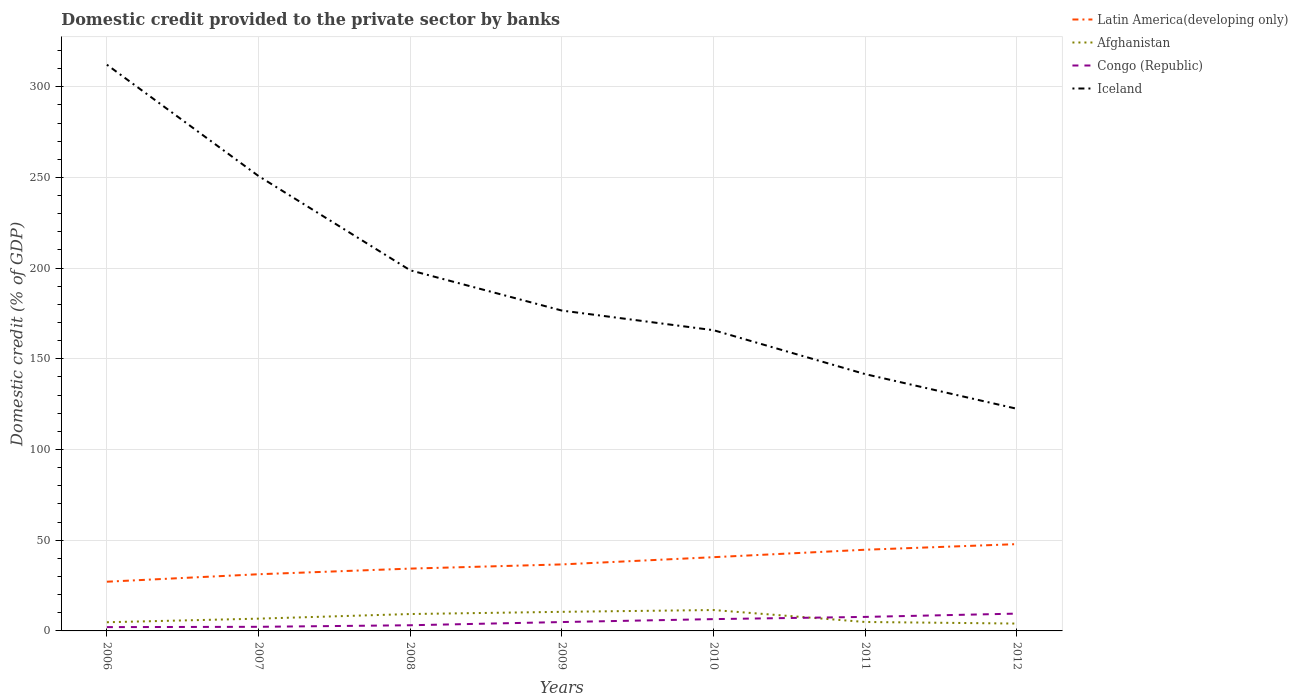How many different coloured lines are there?
Your response must be concise. 4. Is the number of lines equal to the number of legend labels?
Make the answer very short. Yes. Across all years, what is the maximum domestic credit provided to the private sector by banks in Iceland?
Ensure brevity in your answer.  122.46. In which year was the domestic credit provided to the private sector by banks in Afghanistan maximum?
Your answer should be very brief. 2012. What is the total domestic credit provided to the private sector by banks in Afghanistan in the graph?
Your response must be concise. 4.38. What is the difference between the highest and the second highest domestic credit provided to the private sector by banks in Afghanistan?
Give a very brief answer. 7.46. Is the domestic credit provided to the private sector by banks in Latin America(developing only) strictly greater than the domestic credit provided to the private sector by banks in Iceland over the years?
Provide a succinct answer. Yes. How many lines are there?
Your answer should be very brief. 4. How many years are there in the graph?
Offer a terse response. 7. What is the difference between two consecutive major ticks on the Y-axis?
Provide a short and direct response. 50. Are the values on the major ticks of Y-axis written in scientific E-notation?
Offer a terse response. No. How are the legend labels stacked?
Provide a short and direct response. Vertical. What is the title of the graph?
Keep it short and to the point. Domestic credit provided to the private sector by banks. Does "United States" appear as one of the legend labels in the graph?
Your answer should be compact. No. What is the label or title of the X-axis?
Your response must be concise. Years. What is the label or title of the Y-axis?
Offer a terse response. Domestic credit (% of GDP). What is the Domestic credit (% of GDP) of Latin America(developing only) in 2006?
Give a very brief answer. 27.13. What is the Domestic credit (% of GDP) in Afghanistan in 2006?
Your response must be concise. 4.78. What is the Domestic credit (% of GDP) in Congo (Republic) in 2006?
Offer a terse response. 2.1. What is the Domestic credit (% of GDP) of Iceland in 2006?
Your response must be concise. 312.15. What is the Domestic credit (% of GDP) in Latin America(developing only) in 2007?
Ensure brevity in your answer.  31.25. What is the Domestic credit (% of GDP) in Afghanistan in 2007?
Offer a very short reply. 6.77. What is the Domestic credit (% of GDP) of Congo (Republic) in 2007?
Your answer should be compact. 2.27. What is the Domestic credit (% of GDP) of Iceland in 2007?
Give a very brief answer. 250.76. What is the Domestic credit (% of GDP) of Latin America(developing only) in 2008?
Offer a very short reply. 34.35. What is the Domestic credit (% of GDP) in Afghanistan in 2008?
Give a very brief answer. 9.31. What is the Domestic credit (% of GDP) in Congo (Republic) in 2008?
Provide a short and direct response. 3.13. What is the Domestic credit (% of GDP) of Iceland in 2008?
Provide a succinct answer. 198.81. What is the Domestic credit (% of GDP) in Latin America(developing only) in 2009?
Make the answer very short. 36.67. What is the Domestic credit (% of GDP) in Afghanistan in 2009?
Your response must be concise. 10.53. What is the Domestic credit (% of GDP) in Congo (Republic) in 2009?
Give a very brief answer. 4.89. What is the Domestic credit (% of GDP) of Iceland in 2009?
Make the answer very short. 176.6. What is the Domestic credit (% of GDP) of Latin America(developing only) in 2010?
Keep it short and to the point. 40.65. What is the Domestic credit (% of GDP) in Afghanistan in 2010?
Your response must be concise. 11.52. What is the Domestic credit (% of GDP) in Congo (Republic) in 2010?
Give a very brief answer. 6.51. What is the Domestic credit (% of GDP) in Iceland in 2010?
Ensure brevity in your answer.  165.78. What is the Domestic credit (% of GDP) of Latin America(developing only) in 2011?
Keep it short and to the point. 44.76. What is the Domestic credit (% of GDP) of Afghanistan in 2011?
Ensure brevity in your answer.  4.93. What is the Domestic credit (% of GDP) of Congo (Republic) in 2011?
Make the answer very short. 7.73. What is the Domestic credit (% of GDP) of Iceland in 2011?
Your answer should be compact. 141.56. What is the Domestic credit (% of GDP) in Latin America(developing only) in 2012?
Give a very brief answer. 47.85. What is the Domestic credit (% of GDP) in Afghanistan in 2012?
Provide a succinct answer. 4.05. What is the Domestic credit (% of GDP) in Congo (Republic) in 2012?
Your answer should be compact. 9.54. What is the Domestic credit (% of GDP) of Iceland in 2012?
Give a very brief answer. 122.46. Across all years, what is the maximum Domestic credit (% of GDP) in Latin America(developing only)?
Offer a terse response. 47.85. Across all years, what is the maximum Domestic credit (% of GDP) in Afghanistan?
Your response must be concise. 11.52. Across all years, what is the maximum Domestic credit (% of GDP) of Congo (Republic)?
Provide a short and direct response. 9.54. Across all years, what is the maximum Domestic credit (% of GDP) of Iceland?
Make the answer very short. 312.15. Across all years, what is the minimum Domestic credit (% of GDP) of Latin America(developing only)?
Your response must be concise. 27.13. Across all years, what is the minimum Domestic credit (% of GDP) of Afghanistan?
Give a very brief answer. 4.05. Across all years, what is the minimum Domestic credit (% of GDP) in Congo (Republic)?
Ensure brevity in your answer.  2.1. Across all years, what is the minimum Domestic credit (% of GDP) in Iceland?
Your response must be concise. 122.46. What is the total Domestic credit (% of GDP) in Latin America(developing only) in the graph?
Provide a short and direct response. 262.65. What is the total Domestic credit (% of GDP) in Afghanistan in the graph?
Your answer should be compact. 51.89. What is the total Domestic credit (% of GDP) of Congo (Republic) in the graph?
Your answer should be very brief. 36.17. What is the total Domestic credit (% of GDP) of Iceland in the graph?
Your answer should be compact. 1368.13. What is the difference between the Domestic credit (% of GDP) in Latin America(developing only) in 2006 and that in 2007?
Your response must be concise. -4.12. What is the difference between the Domestic credit (% of GDP) of Afghanistan in 2006 and that in 2007?
Ensure brevity in your answer.  -1.99. What is the difference between the Domestic credit (% of GDP) in Congo (Republic) in 2006 and that in 2007?
Keep it short and to the point. -0.17. What is the difference between the Domestic credit (% of GDP) of Iceland in 2006 and that in 2007?
Offer a very short reply. 61.39. What is the difference between the Domestic credit (% of GDP) in Latin America(developing only) in 2006 and that in 2008?
Provide a short and direct response. -7.22. What is the difference between the Domestic credit (% of GDP) in Afghanistan in 2006 and that in 2008?
Your answer should be very brief. -4.53. What is the difference between the Domestic credit (% of GDP) in Congo (Republic) in 2006 and that in 2008?
Give a very brief answer. -1.03. What is the difference between the Domestic credit (% of GDP) in Iceland in 2006 and that in 2008?
Make the answer very short. 113.35. What is the difference between the Domestic credit (% of GDP) of Latin America(developing only) in 2006 and that in 2009?
Provide a short and direct response. -9.54. What is the difference between the Domestic credit (% of GDP) of Afghanistan in 2006 and that in 2009?
Offer a terse response. -5.74. What is the difference between the Domestic credit (% of GDP) of Congo (Republic) in 2006 and that in 2009?
Your response must be concise. -2.79. What is the difference between the Domestic credit (% of GDP) in Iceland in 2006 and that in 2009?
Your answer should be very brief. 135.55. What is the difference between the Domestic credit (% of GDP) of Latin America(developing only) in 2006 and that in 2010?
Your response must be concise. -13.52. What is the difference between the Domestic credit (% of GDP) in Afghanistan in 2006 and that in 2010?
Make the answer very short. -6.73. What is the difference between the Domestic credit (% of GDP) of Congo (Republic) in 2006 and that in 2010?
Provide a succinct answer. -4.41. What is the difference between the Domestic credit (% of GDP) of Iceland in 2006 and that in 2010?
Offer a very short reply. 146.37. What is the difference between the Domestic credit (% of GDP) in Latin America(developing only) in 2006 and that in 2011?
Your answer should be compact. -17.63. What is the difference between the Domestic credit (% of GDP) in Afghanistan in 2006 and that in 2011?
Your answer should be very brief. -0.14. What is the difference between the Domestic credit (% of GDP) in Congo (Republic) in 2006 and that in 2011?
Provide a succinct answer. -5.63. What is the difference between the Domestic credit (% of GDP) of Iceland in 2006 and that in 2011?
Offer a terse response. 170.59. What is the difference between the Domestic credit (% of GDP) in Latin America(developing only) in 2006 and that in 2012?
Keep it short and to the point. -20.72. What is the difference between the Domestic credit (% of GDP) of Afghanistan in 2006 and that in 2012?
Your response must be concise. 0.73. What is the difference between the Domestic credit (% of GDP) of Congo (Republic) in 2006 and that in 2012?
Ensure brevity in your answer.  -7.45. What is the difference between the Domestic credit (% of GDP) of Iceland in 2006 and that in 2012?
Ensure brevity in your answer.  189.69. What is the difference between the Domestic credit (% of GDP) in Latin America(developing only) in 2007 and that in 2008?
Keep it short and to the point. -3.11. What is the difference between the Domestic credit (% of GDP) in Afghanistan in 2007 and that in 2008?
Keep it short and to the point. -2.54. What is the difference between the Domestic credit (% of GDP) of Congo (Republic) in 2007 and that in 2008?
Your answer should be very brief. -0.86. What is the difference between the Domestic credit (% of GDP) in Iceland in 2007 and that in 2008?
Offer a terse response. 51.96. What is the difference between the Domestic credit (% of GDP) in Latin America(developing only) in 2007 and that in 2009?
Offer a terse response. -5.42. What is the difference between the Domestic credit (% of GDP) of Afghanistan in 2007 and that in 2009?
Your answer should be compact. -3.76. What is the difference between the Domestic credit (% of GDP) in Congo (Republic) in 2007 and that in 2009?
Your response must be concise. -2.62. What is the difference between the Domestic credit (% of GDP) of Iceland in 2007 and that in 2009?
Provide a short and direct response. 74.16. What is the difference between the Domestic credit (% of GDP) in Latin America(developing only) in 2007 and that in 2010?
Your response must be concise. -9.4. What is the difference between the Domestic credit (% of GDP) in Afghanistan in 2007 and that in 2010?
Provide a short and direct response. -4.75. What is the difference between the Domestic credit (% of GDP) of Congo (Republic) in 2007 and that in 2010?
Your answer should be very brief. -4.24. What is the difference between the Domestic credit (% of GDP) of Iceland in 2007 and that in 2010?
Keep it short and to the point. 84.98. What is the difference between the Domestic credit (% of GDP) of Latin America(developing only) in 2007 and that in 2011?
Ensure brevity in your answer.  -13.51. What is the difference between the Domestic credit (% of GDP) of Afghanistan in 2007 and that in 2011?
Give a very brief answer. 1.84. What is the difference between the Domestic credit (% of GDP) in Congo (Republic) in 2007 and that in 2011?
Offer a terse response. -5.46. What is the difference between the Domestic credit (% of GDP) in Iceland in 2007 and that in 2011?
Keep it short and to the point. 109.2. What is the difference between the Domestic credit (% of GDP) of Latin America(developing only) in 2007 and that in 2012?
Your response must be concise. -16.6. What is the difference between the Domestic credit (% of GDP) in Afghanistan in 2007 and that in 2012?
Offer a terse response. 2.72. What is the difference between the Domestic credit (% of GDP) in Congo (Republic) in 2007 and that in 2012?
Your answer should be compact. -7.28. What is the difference between the Domestic credit (% of GDP) of Iceland in 2007 and that in 2012?
Your answer should be very brief. 128.3. What is the difference between the Domestic credit (% of GDP) in Latin America(developing only) in 2008 and that in 2009?
Give a very brief answer. -2.31. What is the difference between the Domestic credit (% of GDP) of Afghanistan in 2008 and that in 2009?
Offer a very short reply. -1.21. What is the difference between the Domestic credit (% of GDP) of Congo (Republic) in 2008 and that in 2009?
Make the answer very short. -1.77. What is the difference between the Domestic credit (% of GDP) of Iceland in 2008 and that in 2009?
Your response must be concise. 22.2. What is the difference between the Domestic credit (% of GDP) in Latin America(developing only) in 2008 and that in 2010?
Provide a short and direct response. -6.3. What is the difference between the Domestic credit (% of GDP) of Afghanistan in 2008 and that in 2010?
Provide a succinct answer. -2.2. What is the difference between the Domestic credit (% of GDP) of Congo (Republic) in 2008 and that in 2010?
Make the answer very short. -3.38. What is the difference between the Domestic credit (% of GDP) in Iceland in 2008 and that in 2010?
Give a very brief answer. 33.02. What is the difference between the Domestic credit (% of GDP) in Latin America(developing only) in 2008 and that in 2011?
Offer a terse response. -10.41. What is the difference between the Domestic credit (% of GDP) in Afghanistan in 2008 and that in 2011?
Offer a terse response. 4.38. What is the difference between the Domestic credit (% of GDP) in Congo (Republic) in 2008 and that in 2011?
Offer a very short reply. -4.61. What is the difference between the Domestic credit (% of GDP) of Iceland in 2008 and that in 2011?
Your response must be concise. 57.25. What is the difference between the Domestic credit (% of GDP) of Latin America(developing only) in 2008 and that in 2012?
Provide a short and direct response. -13.49. What is the difference between the Domestic credit (% of GDP) of Afghanistan in 2008 and that in 2012?
Provide a short and direct response. 5.26. What is the difference between the Domestic credit (% of GDP) of Congo (Republic) in 2008 and that in 2012?
Your answer should be compact. -6.42. What is the difference between the Domestic credit (% of GDP) in Iceland in 2008 and that in 2012?
Make the answer very short. 76.35. What is the difference between the Domestic credit (% of GDP) in Latin America(developing only) in 2009 and that in 2010?
Keep it short and to the point. -3.98. What is the difference between the Domestic credit (% of GDP) in Afghanistan in 2009 and that in 2010?
Your response must be concise. -0.99. What is the difference between the Domestic credit (% of GDP) of Congo (Republic) in 2009 and that in 2010?
Make the answer very short. -1.62. What is the difference between the Domestic credit (% of GDP) of Iceland in 2009 and that in 2010?
Offer a terse response. 10.82. What is the difference between the Domestic credit (% of GDP) of Latin America(developing only) in 2009 and that in 2011?
Provide a short and direct response. -8.09. What is the difference between the Domestic credit (% of GDP) in Afghanistan in 2009 and that in 2011?
Keep it short and to the point. 5.6. What is the difference between the Domestic credit (% of GDP) of Congo (Republic) in 2009 and that in 2011?
Give a very brief answer. -2.84. What is the difference between the Domestic credit (% of GDP) of Iceland in 2009 and that in 2011?
Keep it short and to the point. 35.04. What is the difference between the Domestic credit (% of GDP) of Latin America(developing only) in 2009 and that in 2012?
Give a very brief answer. -11.18. What is the difference between the Domestic credit (% of GDP) in Afghanistan in 2009 and that in 2012?
Your answer should be compact. 6.47. What is the difference between the Domestic credit (% of GDP) in Congo (Republic) in 2009 and that in 2012?
Offer a terse response. -4.65. What is the difference between the Domestic credit (% of GDP) of Iceland in 2009 and that in 2012?
Make the answer very short. 54.14. What is the difference between the Domestic credit (% of GDP) in Latin America(developing only) in 2010 and that in 2011?
Provide a short and direct response. -4.11. What is the difference between the Domestic credit (% of GDP) in Afghanistan in 2010 and that in 2011?
Your answer should be compact. 6.59. What is the difference between the Domestic credit (% of GDP) of Congo (Republic) in 2010 and that in 2011?
Ensure brevity in your answer.  -1.22. What is the difference between the Domestic credit (% of GDP) in Iceland in 2010 and that in 2011?
Ensure brevity in your answer.  24.22. What is the difference between the Domestic credit (% of GDP) of Latin America(developing only) in 2010 and that in 2012?
Give a very brief answer. -7.19. What is the difference between the Domestic credit (% of GDP) in Afghanistan in 2010 and that in 2012?
Keep it short and to the point. 7.46. What is the difference between the Domestic credit (% of GDP) in Congo (Republic) in 2010 and that in 2012?
Make the answer very short. -3.04. What is the difference between the Domestic credit (% of GDP) in Iceland in 2010 and that in 2012?
Ensure brevity in your answer.  43.32. What is the difference between the Domestic credit (% of GDP) in Latin America(developing only) in 2011 and that in 2012?
Make the answer very short. -3.09. What is the difference between the Domestic credit (% of GDP) in Congo (Republic) in 2011 and that in 2012?
Your answer should be compact. -1.81. What is the difference between the Domestic credit (% of GDP) in Iceland in 2011 and that in 2012?
Your answer should be very brief. 19.1. What is the difference between the Domestic credit (% of GDP) in Latin America(developing only) in 2006 and the Domestic credit (% of GDP) in Afghanistan in 2007?
Your response must be concise. 20.36. What is the difference between the Domestic credit (% of GDP) in Latin America(developing only) in 2006 and the Domestic credit (% of GDP) in Congo (Republic) in 2007?
Offer a terse response. 24.86. What is the difference between the Domestic credit (% of GDP) in Latin America(developing only) in 2006 and the Domestic credit (% of GDP) in Iceland in 2007?
Give a very brief answer. -223.63. What is the difference between the Domestic credit (% of GDP) of Afghanistan in 2006 and the Domestic credit (% of GDP) of Congo (Republic) in 2007?
Provide a succinct answer. 2.52. What is the difference between the Domestic credit (% of GDP) in Afghanistan in 2006 and the Domestic credit (% of GDP) in Iceland in 2007?
Your answer should be compact. -245.98. What is the difference between the Domestic credit (% of GDP) in Congo (Republic) in 2006 and the Domestic credit (% of GDP) in Iceland in 2007?
Your answer should be very brief. -248.67. What is the difference between the Domestic credit (% of GDP) of Latin America(developing only) in 2006 and the Domestic credit (% of GDP) of Afghanistan in 2008?
Keep it short and to the point. 17.82. What is the difference between the Domestic credit (% of GDP) of Latin America(developing only) in 2006 and the Domestic credit (% of GDP) of Congo (Republic) in 2008?
Your answer should be very brief. 24. What is the difference between the Domestic credit (% of GDP) of Latin America(developing only) in 2006 and the Domestic credit (% of GDP) of Iceland in 2008?
Provide a succinct answer. -171.68. What is the difference between the Domestic credit (% of GDP) in Afghanistan in 2006 and the Domestic credit (% of GDP) in Congo (Republic) in 2008?
Provide a succinct answer. 1.66. What is the difference between the Domestic credit (% of GDP) of Afghanistan in 2006 and the Domestic credit (% of GDP) of Iceland in 2008?
Your answer should be compact. -194.02. What is the difference between the Domestic credit (% of GDP) in Congo (Republic) in 2006 and the Domestic credit (% of GDP) in Iceland in 2008?
Provide a short and direct response. -196.71. What is the difference between the Domestic credit (% of GDP) in Latin America(developing only) in 2006 and the Domestic credit (% of GDP) in Afghanistan in 2009?
Keep it short and to the point. 16.6. What is the difference between the Domestic credit (% of GDP) of Latin America(developing only) in 2006 and the Domestic credit (% of GDP) of Congo (Republic) in 2009?
Provide a short and direct response. 22.24. What is the difference between the Domestic credit (% of GDP) of Latin America(developing only) in 2006 and the Domestic credit (% of GDP) of Iceland in 2009?
Offer a very short reply. -149.47. What is the difference between the Domestic credit (% of GDP) in Afghanistan in 2006 and the Domestic credit (% of GDP) in Congo (Republic) in 2009?
Your response must be concise. -0.11. What is the difference between the Domestic credit (% of GDP) in Afghanistan in 2006 and the Domestic credit (% of GDP) in Iceland in 2009?
Provide a succinct answer. -171.82. What is the difference between the Domestic credit (% of GDP) in Congo (Republic) in 2006 and the Domestic credit (% of GDP) in Iceland in 2009?
Offer a terse response. -174.5. What is the difference between the Domestic credit (% of GDP) in Latin America(developing only) in 2006 and the Domestic credit (% of GDP) in Afghanistan in 2010?
Your answer should be compact. 15.61. What is the difference between the Domestic credit (% of GDP) of Latin America(developing only) in 2006 and the Domestic credit (% of GDP) of Congo (Republic) in 2010?
Keep it short and to the point. 20.62. What is the difference between the Domestic credit (% of GDP) of Latin America(developing only) in 2006 and the Domestic credit (% of GDP) of Iceland in 2010?
Keep it short and to the point. -138.66. What is the difference between the Domestic credit (% of GDP) in Afghanistan in 2006 and the Domestic credit (% of GDP) in Congo (Republic) in 2010?
Offer a terse response. -1.73. What is the difference between the Domestic credit (% of GDP) in Afghanistan in 2006 and the Domestic credit (% of GDP) in Iceland in 2010?
Keep it short and to the point. -161. What is the difference between the Domestic credit (% of GDP) in Congo (Republic) in 2006 and the Domestic credit (% of GDP) in Iceland in 2010?
Offer a very short reply. -163.69. What is the difference between the Domestic credit (% of GDP) of Latin America(developing only) in 2006 and the Domestic credit (% of GDP) of Afghanistan in 2011?
Keep it short and to the point. 22.2. What is the difference between the Domestic credit (% of GDP) in Latin America(developing only) in 2006 and the Domestic credit (% of GDP) in Congo (Republic) in 2011?
Provide a short and direct response. 19.4. What is the difference between the Domestic credit (% of GDP) in Latin America(developing only) in 2006 and the Domestic credit (% of GDP) in Iceland in 2011?
Offer a very short reply. -114.43. What is the difference between the Domestic credit (% of GDP) of Afghanistan in 2006 and the Domestic credit (% of GDP) of Congo (Republic) in 2011?
Offer a terse response. -2.95. What is the difference between the Domestic credit (% of GDP) in Afghanistan in 2006 and the Domestic credit (% of GDP) in Iceland in 2011?
Your answer should be very brief. -136.78. What is the difference between the Domestic credit (% of GDP) in Congo (Republic) in 2006 and the Domestic credit (% of GDP) in Iceland in 2011?
Provide a succinct answer. -139.46. What is the difference between the Domestic credit (% of GDP) of Latin America(developing only) in 2006 and the Domestic credit (% of GDP) of Afghanistan in 2012?
Make the answer very short. 23.08. What is the difference between the Domestic credit (% of GDP) in Latin America(developing only) in 2006 and the Domestic credit (% of GDP) in Congo (Republic) in 2012?
Your answer should be compact. 17.58. What is the difference between the Domestic credit (% of GDP) in Latin America(developing only) in 2006 and the Domestic credit (% of GDP) in Iceland in 2012?
Provide a succinct answer. -95.33. What is the difference between the Domestic credit (% of GDP) in Afghanistan in 2006 and the Domestic credit (% of GDP) in Congo (Republic) in 2012?
Keep it short and to the point. -4.76. What is the difference between the Domestic credit (% of GDP) of Afghanistan in 2006 and the Domestic credit (% of GDP) of Iceland in 2012?
Make the answer very short. -117.68. What is the difference between the Domestic credit (% of GDP) in Congo (Republic) in 2006 and the Domestic credit (% of GDP) in Iceland in 2012?
Your answer should be very brief. -120.36. What is the difference between the Domestic credit (% of GDP) in Latin America(developing only) in 2007 and the Domestic credit (% of GDP) in Afghanistan in 2008?
Give a very brief answer. 21.93. What is the difference between the Domestic credit (% of GDP) of Latin America(developing only) in 2007 and the Domestic credit (% of GDP) of Congo (Republic) in 2008?
Ensure brevity in your answer.  28.12. What is the difference between the Domestic credit (% of GDP) of Latin America(developing only) in 2007 and the Domestic credit (% of GDP) of Iceland in 2008?
Your answer should be very brief. -167.56. What is the difference between the Domestic credit (% of GDP) in Afghanistan in 2007 and the Domestic credit (% of GDP) in Congo (Republic) in 2008?
Provide a short and direct response. 3.65. What is the difference between the Domestic credit (% of GDP) of Afghanistan in 2007 and the Domestic credit (% of GDP) of Iceland in 2008?
Give a very brief answer. -192.04. What is the difference between the Domestic credit (% of GDP) in Congo (Republic) in 2007 and the Domestic credit (% of GDP) in Iceland in 2008?
Ensure brevity in your answer.  -196.54. What is the difference between the Domestic credit (% of GDP) in Latin America(developing only) in 2007 and the Domestic credit (% of GDP) in Afghanistan in 2009?
Give a very brief answer. 20.72. What is the difference between the Domestic credit (% of GDP) in Latin America(developing only) in 2007 and the Domestic credit (% of GDP) in Congo (Republic) in 2009?
Provide a short and direct response. 26.36. What is the difference between the Domestic credit (% of GDP) in Latin America(developing only) in 2007 and the Domestic credit (% of GDP) in Iceland in 2009?
Provide a succinct answer. -145.35. What is the difference between the Domestic credit (% of GDP) in Afghanistan in 2007 and the Domestic credit (% of GDP) in Congo (Republic) in 2009?
Ensure brevity in your answer.  1.88. What is the difference between the Domestic credit (% of GDP) in Afghanistan in 2007 and the Domestic credit (% of GDP) in Iceland in 2009?
Offer a very short reply. -169.83. What is the difference between the Domestic credit (% of GDP) in Congo (Republic) in 2007 and the Domestic credit (% of GDP) in Iceland in 2009?
Ensure brevity in your answer.  -174.33. What is the difference between the Domestic credit (% of GDP) in Latin America(developing only) in 2007 and the Domestic credit (% of GDP) in Afghanistan in 2010?
Provide a short and direct response. 19.73. What is the difference between the Domestic credit (% of GDP) of Latin America(developing only) in 2007 and the Domestic credit (% of GDP) of Congo (Republic) in 2010?
Offer a terse response. 24.74. What is the difference between the Domestic credit (% of GDP) in Latin America(developing only) in 2007 and the Domestic credit (% of GDP) in Iceland in 2010?
Ensure brevity in your answer.  -134.54. What is the difference between the Domestic credit (% of GDP) of Afghanistan in 2007 and the Domestic credit (% of GDP) of Congo (Republic) in 2010?
Give a very brief answer. 0.26. What is the difference between the Domestic credit (% of GDP) in Afghanistan in 2007 and the Domestic credit (% of GDP) in Iceland in 2010?
Provide a succinct answer. -159.01. What is the difference between the Domestic credit (% of GDP) of Congo (Republic) in 2007 and the Domestic credit (% of GDP) of Iceland in 2010?
Keep it short and to the point. -163.52. What is the difference between the Domestic credit (% of GDP) of Latin America(developing only) in 2007 and the Domestic credit (% of GDP) of Afghanistan in 2011?
Offer a very short reply. 26.32. What is the difference between the Domestic credit (% of GDP) of Latin America(developing only) in 2007 and the Domestic credit (% of GDP) of Congo (Republic) in 2011?
Your answer should be very brief. 23.52. What is the difference between the Domestic credit (% of GDP) of Latin America(developing only) in 2007 and the Domestic credit (% of GDP) of Iceland in 2011?
Provide a succinct answer. -110.31. What is the difference between the Domestic credit (% of GDP) of Afghanistan in 2007 and the Domestic credit (% of GDP) of Congo (Republic) in 2011?
Offer a terse response. -0.96. What is the difference between the Domestic credit (% of GDP) in Afghanistan in 2007 and the Domestic credit (% of GDP) in Iceland in 2011?
Your answer should be very brief. -134.79. What is the difference between the Domestic credit (% of GDP) of Congo (Republic) in 2007 and the Domestic credit (% of GDP) of Iceland in 2011?
Keep it short and to the point. -139.29. What is the difference between the Domestic credit (% of GDP) in Latin America(developing only) in 2007 and the Domestic credit (% of GDP) in Afghanistan in 2012?
Keep it short and to the point. 27.19. What is the difference between the Domestic credit (% of GDP) in Latin America(developing only) in 2007 and the Domestic credit (% of GDP) in Congo (Republic) in 2012?
Give a very brief answer. 21.7. What is the difference between the Domestic credit (% of GDP) in Latin America(developing only) in 2007 and the Domestic credit (% of GDP) in Iceland in 2012?
Your answer should be compact. -91.21. What is the difference between the Domestic credit (% of GDP) in Afghanistan in 2007 and the Domestic credit (% of GDP) in Congo (Republic) in 2012?
Your answer should be compact. -2.77. What is the difference between the Domestic credit (% of GDP) in Afghanistan in 2007 and the Domestic credit (% of GDP) in Iceland in 2012?
Keep it short and to the point. -115.69. What is the difference between the Domestic credit (% of GDP) in Congo (Republic) in 2007 and the Domestic credit (% of GDP) in Iceland in 2012?
Keep it short and to the point. -120.19. What is the difference between the Domestic credit (% of GDP) of Latin America(developing only) in 2008 and the Domestic credit (% of GDP) of Afghanistan in 2009?
Make the answer very short. 23.83. What is the difference between the Domestic credit (% of GDP) of Latin America(developing only) in 2008 and the Domestic credit (% of GDP) of Congo (Republic) in 2009?
Provide a succinct answer. 29.46. What is the difference between the Domestic credit (% of GDP) of Latin America(developing only) in 2008 and the Domestic credit (% of GDP) of Iceland in 2009?
Give a very brief answer. -142.25. What is the difference between the Domestic credit (% of GDP) in Afghanistan in 2008 and the Domestic credit (% of GDP) in Congo (Republic) in 2009?
Make the answer very short. 4.42. What is the difference between the Domestic credit (% of GDP) in Afghanistan in 2008 and the Domestic credit (% of GDP) in Iceland in 2009?
Your response must be concise. -167.29. What is the difference between the Domestic credit (% of GDP) in Congo (Republic) in 2008 and the Domestic credit (% of GDP) in Iceland in 2009?
Make the answer very short. -173.48. What is the difference between the Domestic credit (% of GDP) in Latin America(developing only) in 2008 and the Domestic credit (% of GDP) in Afghanistan in 2010?
Give a very brief answer. 22.84. What is the difference between the Domestic credit (% of GDP) in Latin America(developing only) in 2008 and the Domestic credit (% of GDP) in Congo (Republic) in 2010?
Give a very brief answer. 27.84. What is the difference between the Domestic credit (% of GDP) of Latin America(developing only) in 2008 and the Domestic credit (% of GDP) of Iceland in 2010?
Make the answer very short. -131.43. What is the difference between the Domestic credit (% of GDP) of Afghanistan in 2008 and the Domestic credit (% of GDP) of Congo (Republic) in 2010?
Offer a terse response. 2.8. What is the difference between the Domestic credit (% of GDP) in Afghanistan in 2008 and the Domestic credit (% of GDP) in Iceland in 2010?
Provide a succinct answer. -156.47. What is the difference between the Domestic credit (% of GDP) of Congo (Republic) in 2008 and the Domestic credit (% of GDP) of Iceland in 2010?
Offer a terse response. -162.66. What is the difference between the Domestic credit (% of GDP) in Latin America(developing only) in 2008 and the Domestic credit (% of GDP) in Afghanistan in 2011?
Ensure brevity in your answer.  29.42. What is the difference between the Domestic credit (% of GDP) of Latin America(developing only) in 2008 and the Domestic credit (% of GDP) of Congo (Republic) in 2011?
Give a very brief answer. 26.62. What is the difference between the Domestic credit (% of GDP) of Latin America(developing only) in 2008 and the Domestic credit (% of GDP) of Iceland in 2011?
Your answer should be very brief. -107.21. What is the difference between the Domestic credit (% of GDP) in Afghanistan in 2008 and the Domestic credit (% of GDP) in Congo (Republic) in 2011?
Offer a very short reply. 1.58. What is the difference between the Domestic credit (% of GDP) in Afghanistan in 2008 and the Domestic credit (% of GDP) in Iceland in 2011?
Offer a terse response. -132.25. What is the difference between the Domestic credit (% of GDP) in Congo (Republic) in 2008 and the Domestic credit (% of GDP) in Iceland in 2011?
Provide a short and direct response. -138.44. What is the difference between the Domestic credit (% of GDP) of Latin America(developing only) in 2008 and the Domestic credit (% of GDP) of Afghanistan in 2012?
Offer a terse response. 30.3. What is the difference between the Domestic credit (% of GDP) of Latin America(developing only) in 2008 and the Domestic credit (% of GDP) of Congo (Republic) in 2012?
Provide a succinct answer. 24.81. What is the difference between the Domestic credit (% of GDP) in Latin America(developing only) in 2008 and the Domestic credit (% of GDP) in Iceland in 2012?
Offer a very short reply. -88.11. What is the difference between the Domestic credit (% of GDP) of Afghanistan in 2008 and the Domestic credit (% of GDP) of Congo (Republic) in 2012?
Provide a short and direct response. -0.23. What is the difference between the Domestic credit (% of GDP) in Afghanistan in 2008 and the Domestic credit (% of GDP) in Iceland in 2012?
Offer a terse response. -113.15. What is the difference between the Domestic credit (% of GDP) in Congo (Republic) in 2008 and the Domestic credit (% of GDP) in Iceland in 2012?
Offer a terse response. -119.33. What is the difference between the Domestic credit (% of GDP) in Latin America(developing only) in 2009 and the Domestic credit (% of GDP) in Afghanistan in 2010?
Ensure brevity in your answer.  25.15. What is the difference between the Domestic credit (% of GDP) in Latin America(developing only) in 2009 and the Domestic credit (% of GDP) in Congo (Republic) in 2010?
Provide a succinct answer. 30.16. What is the difference between the Domestic credit (% of GDP) in Latin America(developing only) in 2009 and the Domestic credit (% of GDP) in Iceland in 2010?
Provide a succinct answer. -129.12. What is the difference between the Domestic credit (% of GDP) of Afghanistan in 2009 and the Domestic credit (% of GDP) of Congo (Republic) in 2010?
Your answer should be compact. 4.02. What is the difference between the Domestic credit (% of GDP) of Afghanistan in 2009 and the Domestic credit (% of GDP) of Iceland in 2010?
Your answer should be very brief. -155.26. What is the difference between the Domestic credit (% of GDP) of Congo (Republic) in 2009 and the Domestic credit (% of GDP) of Iceland in 2010?
Offer a terse response. -160.89. What is the difference between the Domestic credit (% of GDP) in Latin America(developing only) in 2009 and the Domestic credit (% of GDP) in Afghanistan in 2011?
Keep it short and to the point. 31.74. What is the difference between the Domestic credit (% of GDP) of Latin America(developing only) in 2009 and the Domestic credit (% of GDP) of Congo (Republic) in 2011?
Offer a terse response. 28.94. What is the difference between the Domestic credit (% of GDP) in Latin America(developing only) in 2009 and the Domestic credit (% of GDP) in Iceland in 2011?
Your answer should be compact. -104.89. What is the difference between the Domestic credit (% of GDP) in Afghanistan in 2009 and the Domestic credit (% of GDP) in Congo (Republic) in 2011?
Make the answer very short. 2.8. What is the difference between the Domestic credit (% of GDP) of Afghanistan in 2009 and the Domestic credit (% of GDP) of Iceland in 2011?
Offer a very short reply. -131.03. What is the difference between the Domestic credit (% of GDP) of Congo (Republic) in 2009 and the Domestic credit (% of GDP) of Iceland in 2011?
Your answer should be very brief. -136.67. What is the difference between the Domestic credit (% of GDP) in Latin America(developing only) in 2009 and the Domestic credit (% of GDP) in Afghanistan in 2012?
Keep it short and to the point. 32.61. What is the difference between the Domestic credit (% of GDP) in Latin America(developing only) in 2009 and the Domestic credit (% of GDP) in Congo (Republic) in 2012?
Your answer should be very brief. 27.12. What is the difference between the Domestic credit (% of GDP) in Latin America(developing only) in 2009 and the Domestic credit (% of GDP) in Iceland in 2012?
Ensure brevity in your answer.  -85.79. What is the difference between the Domestic credit (% of GDP) of Afghanistan in 2009 and the Domestic credit (% of GDP) of Congo (Republic) in 2012?
Ensure brevity in your answer.  0.98. What is the difference between the Domestic credit (% of GDP) of Afghanistan in 2009 and the Domestic credit (% of GDP) of Iceland in 2012?
Offer a very short reply. -111.93. What is the difference between the Domestic credit (% of GDP) of Congo (Republic) in 2009 and the Domestic credit (% of GDP) of Iceland in 2012?
Make the answer very short. -117.57. What is the difference between the Domestic credit (% of GDP) in Latin America(developing only) in 2010 and the Domestic credit (% of GDP) in Afghanistan in 2011?
Your answer should be compact. 35.72. What is the difference between the Domestic credit (% of GDP) in Latin America(developing only) in 2010 and the Domestic credit (% of GDP) in Congo (Republic) in 2011?
Keep it short and to the point. 32.92. What is the difference between the Domestic credit (% of GDP) of Latin America(developing only) in 2010 and the Domestic credit (% of GDP) of Iceland in 2011?
Offer a terse response. -100.91. What is the difference between the Domestic credit (% of GDP) in Afghanistan in 2010 and the Domestic credit (% of GDP) in Congo (Republic) in 2011?
Offer a very short reply. 3.79. What is the difference between the Domestic credit (% of GDP) in Afghanistan in 2010 and the Domestic credit (% of GDP) in Iceland in 2011?
Offer a very short reply. -130.04. What is the difference between the Domestic credit (% of GDP) of Congo (Republic) in 2010 and the Domestic credit (% of GDP) of Iceland in 2011?
Your answer should be compact. -135.05. What is the difference between the Domestic credit (% of GDP) in Latin America(developing only) in 2010 and the Domestic credit (% of GDP) in Afghanistan in 2012?
Your answer should be compact. 36.6. What is the difference between the Domestic credit (% of GDP) in Latin America(developing only) in 2010 and the Domestic credit (% of GDP) in Congo (Republic) in 2012?
Provide a short and direct response. 31.11. What is the difference between the Domestic credit (% of GDP) of Latin America(developing only) in 2010 and the Domestic credit (% of GDP) of Iceland in 2012?
Keep it short and to the point. -81.81. What is the difference between the Domestic credit (% of GDP) of Afghanistan in 2010 and the Domestic credit (% of GDP) of Congo (Republic) in 2012?
Provide a succinct answer. 1.97. What is the difference between the Domestic credit (% of GDP) of Afghanistan in 2010 and the Domestic credit (% of GDP) of Iceland in 2012?
Offer a terse response. -110.94. What is the difference between the Domestic credit (% of GDP) in Congo (Republic) in 2010 and the Domestic credit (% of GDP) in Iceland in 2012?
Provide a short and direct response. -115.95. What is the difference between the Domestic credit (% of GDP) in Latin America(developing only) in 2011 and the Domestic credit (% of GDP) in Afghanistan in 2012?
Your answer should be very brief. 40.71. What is the difference between the Domestic credit (% of GDP) of Latin America(developing only) in 2011 and the Domestic credit (% of GDP) of Congo (Republic) in 2012?
Your response must be concise. 35.21. What is the difference between the Domestic credit (% of GDP) in Latin America(developing only) in 2011 and the Domestic credit (% of GDP) in Iceland in 2012?
Ensure brevity in your answer.  -77.7. What is the difference between the Domestic credit (% of GDP) in Afghanistan in 2011 and the Domestic credit (% of GDP) in Congo (Republic) in 2012?
Offer a terse response. -4.62. What is the difference between the Domestic credit (% of GDP) of Afghanistan in 2011 and the Domestic credit (% of GDP) of Iceland in 2012?
Your answer should be compact. -117.53. What is the difference between the Domestic credit (% of GDP) of Congo (Republic) in 2011 and the Domestic credit (% of GDP) of Iceland in 2012?
Your answer should be very brief. -114.73. What is the average Domestic credit (% of GDP) of Latin America(developing only) per year?
Offer a very short reply. 37.52. What is the average Domestic credit (% of GDP) in Afghanistan per year?
Provide a short and direct response. 7.41. What is the average Domestic credit (% of GDP) of Congo (Republic) per year?
Provide a short and direct response. 5.17. What is the average Domestic credit (% of GDP) of Iceland per year?
Offer a very short reply. 195.45. In the year 2006, what is the difference between the Domestic credit (% of GDP) of Latin America(developing only) and Domestic credit (% of GDP) of Afghanistan?
Make the answer very short. 22.34. In the year 2006, what is the difference between the Domestic credit (% of GDP) in Latin America(developing only) and Domestic credit (% of GDP) in Congo (Republic)?
Your answer should be very brief. 25.03. In the year 2006, what is the difference between the Domestic credit (% of GDP) in Latin America(developing only) and Domestic credit (% of GDP) in Iceland?
Ensure brevity in your answer.  -285.02. In the year 2006, what is the difference between the Domestic credit (% of GDP) of Afghanistan and Domestic credit (% of GDP) of Congo (Republic)?
Your response must be concise. 2.69. In the year 2006, what is the difference between the Domestic credit (% of GDP) in Afghanistan and Domestic credit (% of GDP) in Iceland?
Keep it short and to the point. -307.37. In the year 2006, what is the difference between the Domestic credit (% of GDP) in Congo (Republic) and Domestic credit (% of GDP) in Iceland?
Provide a succinct answer. -310.06. In the year 2007, what is the difference between the Domestic credit (% of GDP) of Latin America(developing only) and Domestic credit (% of GDP) of Afghanistan?
Your answer should be compact. 24.48. In the year 2007, what is the difference between the Domestic credit (% of GDP) in Latin America(developing only) and Domestic credit (% of GDP) in Congo (Republic)?
Your response must be concise. 28.98. In the year 2007, what is the difference between the Domestic credit (% of GDP) in Latin America(developing only) and Domestic credit (% of GDP) in Iceland?
Provide a succinct answer. -219.52. In the year 2007, what is the difference between the Domestic credit (% of GDP) in Afghanistan and Domestic credit (% of GDP) in Congo (Republic)?
Your answer should be compact. 4.5. In the year 2007, what is the difference between the Domestic credit (% of GDP) of Afghanistan and Domestic credit (% of GDP) of Iceland?
Provide a succinct answer. -243.99. In the year 2007, what is the difference between the Domestic credit (% of GDP) in Congo (Republic) and Domestic credit (% of GDP) in Iceland?
Keep it short and to the point. -248.5. In the year 2008, what is the difference between the Domestic credit (% of GDP) in Latin America(developing only) and Domestic credit (% of GDP) in Afghanistan?
Offer a very short reply. 25.04. In the year 2008, what is the difference between the Domestic credit (% of GDP) of Latin America(developing only) and Domestic credit (% of GDP) of Congo (Republic)?
Your response must be concise. 31.23. In the year 2008, what is the difference between the Domestic credit (% of GDP) of Latin America(developing only) and Domestic credit (% of GDP) of Iceland?
Offer a very short reply. -164.45. In the year 2008, what is the difference between the Domestic credit (% of GDP) of Afghanistan and Domestic credit (% of GDP) of Congo (Republic)?
Provide a short and direct response. 6.19. In the year 2008, what is the difference between the Domestic credit (% of GDP) in Afghanistan and Domestic credit (% of GDP) in Iceland?
Your response must be concise. -189.49. In the year 2008, what is the difference between the Domestic credit (% of GDP) of Congo (Republic) and Domestic credit (% of GDP) of Iceland?
Offer a terse response. -195.68. In the year 2009, what is the difference between the Domestic credit (% of GDP) of Latin America(developing only) and Domestic credit (% of GDP) of Afghanistan?
Give a very brief answer. 26.14. In the year 2009, what is the difference between the Domestic credit (% of GDP) of Latin America(developing only) and Domestic credit (% of GDP) of Congo (Republic)?
Offer a very short reply. 31.77. In the year 2009, what is the difference between the Domestic credit (% of GDP) of Latin America(developing only) and Domestic credit (% of GDP) of Iceland?
Your answer should be compact. -139.94. In the year 2009, what is the difference between the Domestic credit (% of GDP) of Afghanistan and Domestic credit (% of GDP) of Congo (Republic)?
Provide a succinct answer. 5.63. In the year 2009, what is the difference between the Domestic credit (% of GDP) of Afghanistan and Domestic credit (% of GDP) of Iceland?
Offer a terse response. -166.08. In the year 2009, what is the difference between the Domestic credit (% of GDP) of Congo (Republic) and Domestic credit (% of GDP) of Iceland?
Make the answer very short. -171.71. In the year 2010, what is the difference between the Domestic credit (% of GDP) in Latin America(developing only) and Domestic credit (% of GDP) in Afghanistan?
Make the answer very short. 29.13. In the year 2010, what is the difference between the Domestic credit (% of GDP) in Latin America(developing only) and Domestic credit (% of GDP) in Congo (Republic)?
Offer a terse response. 34.14. In the year 2010, what is the difference between the Domestic credit (% of GDP) of Latin America(developing only) and Domestic credit (% of GDP) of Iceland?
Provide a short and direct response. -125.13. In the year 2010, what is the difference between the Domestic credit (% of GDP) of Afghanistan and Domestic credit (% of GDP) of Congo (Republic)?
Make the answer very short. 5.01. In the year 2010, what is the difference between the Domestic credit (% of GDP) in Afghanistan and Domestic credit (% of GDP) in Iceland?
Your answer should be compact. -154.27. In the year 2010, what is the difference between the Domestic credit (% of GDP) of Congo (Republic) and Domestic credit (% of GDP) of Iceland?
Give a very brief answer. -159.27. In the year 2011, what is the difference between the Domestic credit (% of GDP) in Latin America(developing only) and Domestic credit (% of GDP) in Afghanistan?
Make the answer very short. 39.83. In the year 2011, what is the difference between the Domestic credit (% of GDP) in Latin America(developing only) and Domestic credit (% of GDP) in Congo (Republic)?
Your answer should be very brief. 37.03. In the year 2011, what is the difference between the Domestic credit (% of GDP) of Latin America(developing only) and Domestic credit (% of GDP) of Iceland?
Provide a short and direct response. -96.8. In the year 2011, what is the difference between the Domestic credit (% of GDP) of Afghanistan and Domestic credit (% of GDP) of Congo (Republic)?
Ensure brevity in your answer.  -2.8. In the year 2011, what is the difference between the Domestic credit (% of GDP) of Afghanistan and Domestic credit (% of GDP) of Iceland?
Your answer should be very brief. -136.63. In the year 2011, what is the difference between the Domestic credit (% of GDP) of Congo (Republic) and Domestic credit (% of GDP) of Iceland?
Your answer should be very brief. -133.83. In the year 2012, what is the difference between the Domestic credit (% of GDP) in Latin America(developing only) and Domestic credit (% of GDP) in Afghanistan?
Provide a succinct answer. 43.79. In the year 2012, what is the difference between the Domestic credit (% of GDP) in Latin America(developing only) and Domestic credit (% of GDP) in Congo (Republic)?
Offer a terse response. 38.3. In the year 2012, what is the difference between the Domestic credit (% of GDP) in Latin America(developing only) and Domestic credit (% of GDP) in Iceland?
Make the answer very short. -74.61. In the year 2012, what is the difference between the Domestic credit (% of GDP) of Afghanistan and Domestic credit (% of GDP) of Congo (Republic)?
Keep it short and to the point. -5.49. In the year 2012, what is the difference between the Domestic credit (% of GDP) in Afghanistan and Domestic credit (% of GDP) in Iceland?
Ensure brevity in your answer.  -118.41. In the year 2012, what is the difference between the Domestic credit (% of GDP) of Congo (Republic) and Domestic credit (% of GDP) of Iceland?
Your answer should be compact. -112.92. What is the ratio of the Domestic credit (% of GDP) of Latin America(developing only) in 2006 to that in 2007?
Ensure brevity in your answer.  0.87. What is the ratio of the Domestic credit (% of GDP) in Afghanistan in 2006 to that in 2007?
Provide a short and direct response. 0.71. What is the ratio of the Domestic credit (% of GDP) of Congo (Republic) in 2006 to that in 2007?
Ensure brevity in your answer.  0.93. What is the ratio of the Domestic credit (% of GDP) of Iceland in 2006 to that in 2007?
Give a very brief answer. 1.24. What is the ratio of the Domestic credit (% of GDP) in Latin America(developing only) in 2006 to that in 2008?
Give a very brief answer. 0.79. What is the ratio of the Domestic credit (% of GDP) in Afghanistan in 2006 to that in 2008?
Ensure brevity in your answer.  0.51. What is the ratio of the Domestic credit (% of GDP) in Congo (Republic) in 2006 to that in 2008?
Provide a short and direct response. 0.67. What is the ratio of the Domestic credit (% of GDP) of Iceland in 2006 to that in 2008?
Offer a very short reply. 1.57. What is the ratio of the Domestic credit (% of GDP) in Latin America(developing only) in 2006 to that in 2009?
Your response must be concise. 0.74. What is the ratio of the Domestic credit (% of GDP) in Afghanistan in 2006 to that in 2009?
Provide a succinct answer. 0.45. What is the ratio of the Domestic credit (% of GDP) of Congo (Republic) in 2006 to that in 2009?
Your answer should be compact. 0.43. What is the ratio of the Domestic credit (% of GDP) in Iceland in 2006 to that in 2009?
Your response must be concise. 1.77. What is the ratio of the Domestic credit (% of GDP) in Latin America(developing only) in 2006 to that in 2010?
Your answer should be very brief. 0.67. What is the ratio of the Domestic credit (% of GDP) in Afghanistan in 2006 to that in 2010?
Provide a succinct answer. 0.42. What is the ratio of the Domestic credit (% of GDP) of Congo (Republic) in 2006 to that in 2010?
Provide a short and direct response. 0.32. What is the ratio of the Domestic credit (% of GDP) in Iceland in 2006 to that in 2010?
Provide a short and direct response. 1.88. What is the ratio of the Domestic credit (% of GDP) of Latin America(developing only) in 2006 to that in 2011?
Offer a very short reply. 0.61. What is the ratio of the Domestic credit (% of GDP) in Afghanistan in 2006 to that in 2011?
Keep it short and to the point. 0.97. What is the ratio of the Domestic credit (% of GDP) in Congo (Republic) in 2006 to that in 2011?
Your answer should be compact. 0.27. What is the ratio of the Domestic credit (% of GDP) of Iceland in 2006 to that in 2011?
Your answer should be compact. 2.21. What is the ratio of the Domestic credit (% of GDP) of Latin America(developing only) in 2006 to that in 2012?
Your answer should be compact. 0.57. What is the ratio of the Domestic credit (% of GDP) in Afghanistan in 2006 to that in 2012?
Ensure brevity in your answer.  1.18. What is the ratio of the Domestic credit (% of GDP) of Congo (Republic) in 2006 to that in 2012?
Your answer should be compact. 0.22. What is the ratio of the Domestic credit (% of GDP) of Iceland in 2006 to that in 2012?
Ensure brevity in your answer.  2.55. What is the ratio of the Domestic credit (% of GDP) of Latin America(developing only) in 2007 to that in 2008?
Keep it short and to the point. 0.91. What is the ratio of the Domestic credit (% of GDP) in Afghanistan in 2007 to that in 2008?
Your response must be concise. 0.73. What is the ratio of the Domestic credit (% of GDP) in Congo (Republic) in 2007 to that in 2008?
Provide a succinct answer. 0.73. What is the ratio of the Domestic credit (% of GDP) of Iceland in 2007 to that in 2008?
Your answer should be compact. 1.26. What is the ratio of the Domestic credit (% of GDP) of Latin America(developing only) in 2007 to that in 2009?
Your answer should be very brief. 0.85. What is the ratio of the Domestic credit (% of GDP) in Afghanistan in 2007 to that in 2009?
Give a very brief answer. 0.64. What is the ratio of the Domestic credit (% of GDP) of Congo (Republic) in 2007 to that in 2009?
Your response must be concise. 0.46. What is the ratio of the Domestic credit (% of GDP) of Iceland in 2007 to that in 2009?
Offer a terse response. 1.42. What is the ratio of the Domestic credit (% of GDP) in Latin America(developing only) in 2007 to that in 2010?
Provide a short and direct response. 0.77. What is the ratio of the Domestic credit (% of GDP) of Afghanistan in 2007 to that in 2010?
Provide a short and direct response. 0.59. What is the ratio of the Domestic credit (% of GDP) in Congo (Republic) in 2007 to that in 2010?
Offer a very short reply. 0.35. What is the ratio of the Domestic credit (% of GDP) of Iceland in 2007 to that in 2010?
Offer a very short reply. 1.51. What is the ratio of the Domestic credit (% of GDP) in Latin America(developing only) in 2007 to that in 2011?
Ensure brevity in your answer.  0.7. What is the ratio of the Domestic credit (% of GDP) in Afghanistan in 2007 to that in 2011?
Make the answer very short. 1.37. What is the ratio of the Domestic credit (% of GDP) in Congo (Republic) in 2007 to that in 2011?
Ensure brevity in your answer.  0.29. What is the ratio of the Domestic credit (% of GDP) of Iceland in 2007 to that in 2011?
Your response must be concise. 1.77. What is the ratio of the Domestic credit (% of GDP) of Latin America(developing only) in 2007 to that in 2012?
Offer a very short reply. 0.65. What is the ratio of the Domestic credit (% of GDP) of Afghanistan in 2007 to that in 2012?
Your answer should be very brief. 1.67. What is the ratio of the Domestic credit (% of GDP) of Congo (Republic) in 2007 to that in 2012?
Provide a short and direct response. 0.24. What is the ratio of the Domestic credit (% of GDP) in Iceland in 2007 to that in 2012?
Offer a very short reply. 2.05. What is the ratio of the Domestic credit (% of GDP) in Latin America(developing only) in 2008 to that in 2009?
Make the answer very short. 0.94. What is the ratio of the Domestic credit (% of GDP) in Afghanistan in 2008 to that in 2009?
Your answer should be very brief. 0.88. What is the ratio of the Domestic credit (% of GDP) in Congo (Republic) in 2008 to that in 2009?
Give a very brief answer. 0.64. What is the ratio of the Domestic credit (% of GDP) in Iceland in 2008 to that in 2009?
Ensure brevity in your answer.  1.13. What is the ratio of the Domestic credit (% of GDP) of Latin America(developing only) in 2008 to that in 2010?
Offer a terse response. 0.85. What is the ratio of the Domestic credit (% of GDP) in Afghanistan in 2008 to that in 2010?
Offer a very short reply. 0.81. What is the ratio of the Domestic credit (% of GDP) of Congo (Republic) in 2008 to that in 2010?
Offer a very short reply. 0.48. What is the ratio of the Domestic credit (% of GDP) of Iceland in 2008 to that in 2010?
Your answer should be compact. 1.2. What is the ratio of the Domestic credit (% of GDP) of Latin America(developing only) in 2008 to that in 2011?
Ensure brevity in your answer.  0.77. What is the ratio of the Domestic credit (% of GDP) in Afghanistan in 2008 to that in 2011?
Provide a short and direct response. 1.89. What is the ratio of the Domestic credit (% of GDP) of Congo (Republic) in 2008 to that in 2011?
Your answer should be compact. 0.4. What is the ratio of the Domestic credit (% of GDP) in Iceland in 2008 to that in 2011?
Your response must be concise. 1.4. What is the ratio of the Domestic credit (% of GDP) in Latin America(developing only) in 2008 to that in 2012?
Give a very brief answer. 0.72. What is the ratio of the Domestic credit (% of GDP) in Afghanistan in 2008 to that in 2012?
Provide a succinct answer. 2.3. What is the ratio of the Domestic credit (% of GDP) in Congo (Republic) in 2008 to that in 2012?
Make the answer very short. 0.33. What is the ratio of the Domestic credit (% of GDP) in Iceland in 2008 to that in 2012?
Make the answer very short. 1.62. What is the ratio of the Domestic credit (% of GDP) in Latin America(developing only) in 2009 to that in 2010?
Give a very brief answer. 0.9. What is the ratio of the Domestic credit (% of GDP) in Afghanistan in 2009 to that in 2010?
Make the answer very short. 0.91. What is the ratio of the Domestic credit (% of GDP) of Congo (Republic) in 2009 to that in 2010?
Ensure brevity in your answer.  0.75. What is the ratio of the Domestic credit (% of GDP) of Iceland in 2009 to that in 2010?
Provide a short and direct response. 1.07. What is the ratio of the Domestic credit (% of GDP) in Latin America(developing only) in 2009 to that in 2011?
Keep it short and to the point. 0.82. What is the ratio of the Domestic credit (% of GDP) of Afghanistan in 2009 to that in 2011?
Offer a terse response. 2.14. What is the ratio of the Domestic credit (% of GDP) in Congo (Republic) in 2009 to that in 2011?
Provide a succinct answer. 0.63. What is the ratio of the Domestic credit (% of GDP) in Iceland in 2009 to that in 2011?
Offer a very short reply. 1.25. What is the ratio of the Domestic credit (% of GDP) of Latin America(developing only) in 2009 to that in 2012?
Give a very brief answer. 0.77. What is the ratio of the Domestic credit (% of GDP) of Afghanistan in 2009 to that in 2012?
Ensure brevity in your answer.  2.6. What is the ratio of the Domestic credit (% of GDP) of Congo (Republic) in 2009 to that in 2012?
Offer a very short reply. 0.51. What is the ratio of the Domestic credit (% of GDP) in Iceland in 2009 to that in 2012?
Make the answer very short. 1.44. What is the ratio of the Domestic credit (% of GDP) in Latin America(developing only) in 2010 to that in 2011?
Offer a terse response. 0.91. What is the ratio of the Domestic credit (% of GDP) of Afghanistan in 2010 to that in 2011?
Offer a very short reply. 2.34. What is the ratio of the Domestic credit (% of GDP) in Congo (Republic) in 2010 to that in 2011?
Make the answer very short. 0.84. What is the ratio of the Domestic credit (% of GDP) of Iceland in 2010 to that in 2011?
Your answer should be very brief. 1.17. What is the ratio of the Domestic credit (% of GDP) of Latin America(developing only) in 2010 to that in 2012?
Make the answer very short. 0.85. What is the ratio of the Domestic credit (% of GDP) of Afghanistan in 2010 to that in 2012?
Provide a short and direct response. 2.84. What is the ratio of the Domestic credit (% of GDP) of Congo (Republic) in 2010 to that in 2012?
Offer a very short reply. 0.68. What is the ratio of the Domestic credit (% of GDP) of Iceland in 2010 to that in 2012?
Your response must be concise. 1.35. What is the ratio of the Domestic credit (% of GDP) of Latin America(developing only) in 2011 to that in 2012?
Provide a short and direct response. 0.94. What is the ratio of the Domestic credit (% of GDP) in Afghanistan in 2011 to that in 2012?
Make the answer very short. 1.22. What is the ratio of the Domestic credit (% of GDP) of Congo (Republic) in 2011 to that in 2012?
Make the answer very short. 0.81. What is the ratio of the Domestic credit (% of GDP) of Iceland in 2011 to that in 2012?
Your response must be concise. 1.16. What is the difference between the highest and the second highest Domestic credit (% of GDP) of Latin America(developing only)?
Provide a succinct answer. 3.09. What is the difference between the highest and the second highest Domestic credit (% of GDP) in Afghanistan?
Provide a succinct answer. 0.99. What is the difference between the highest and the second highest Domestic credit (% of GDP) of Congo (Republic)?
Your response must be concise. 1.81. What is the difference between the highest and the second highest Domestic credit (% of GDP) of Iceland?
Your answer should be compact. 61.39. What is the difference between the highest and the lowest Domestic credit (% of GDP) in Latin America(developing only)?
Your answer should be compact. 20.72. What is the difference between the highest and the lowest Domestic credit (% of GDP) of Afghanistan?
Offer a very short reply. 7.46. What is the difference between the highest and the lowest Domestic credit (% of GDP) of Congo (Republic)?
Your answer should be very brief. 7.45. What is the difference between the highest and the lowest Domestic credit (% of GDP) in Iceland?
Ensure brevity in your answer.  189.69. 